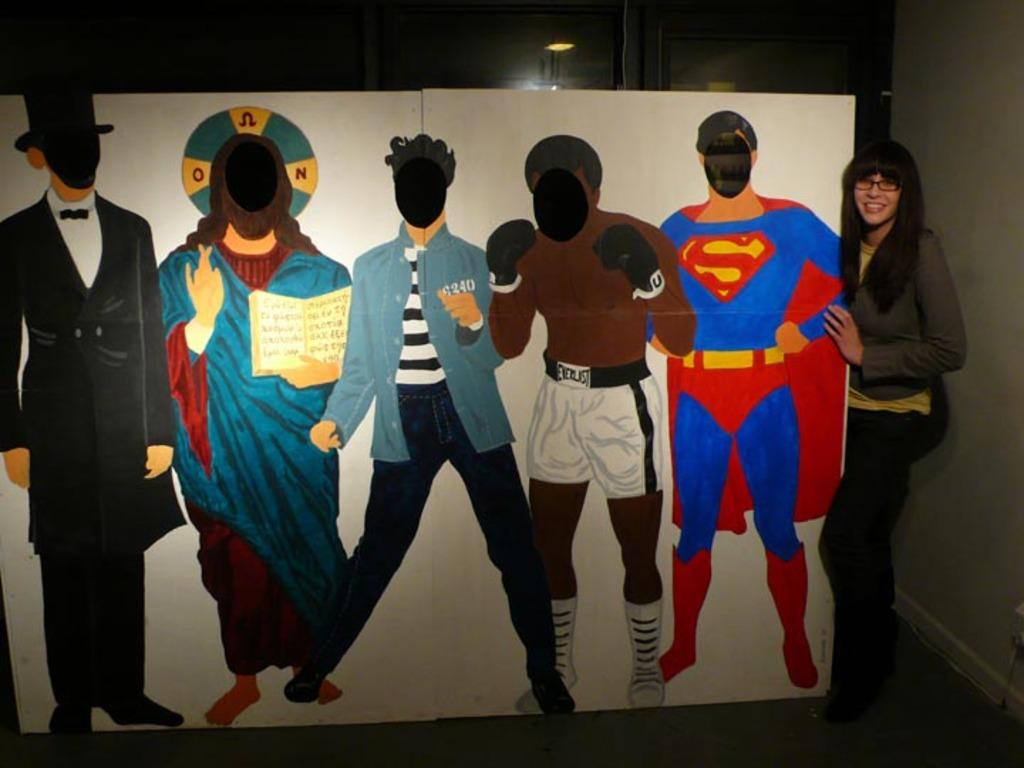What is the main object in the image? There is a board in the image. What can be seen on the board? The board has paintings of persons. Who is present in the image besides the painted persons? There is a woman standing in the image. What is the woman holding? The woman is holding something. What type of account is the woman opening in the image? There is no indication of an account or any financial activity in the image. 